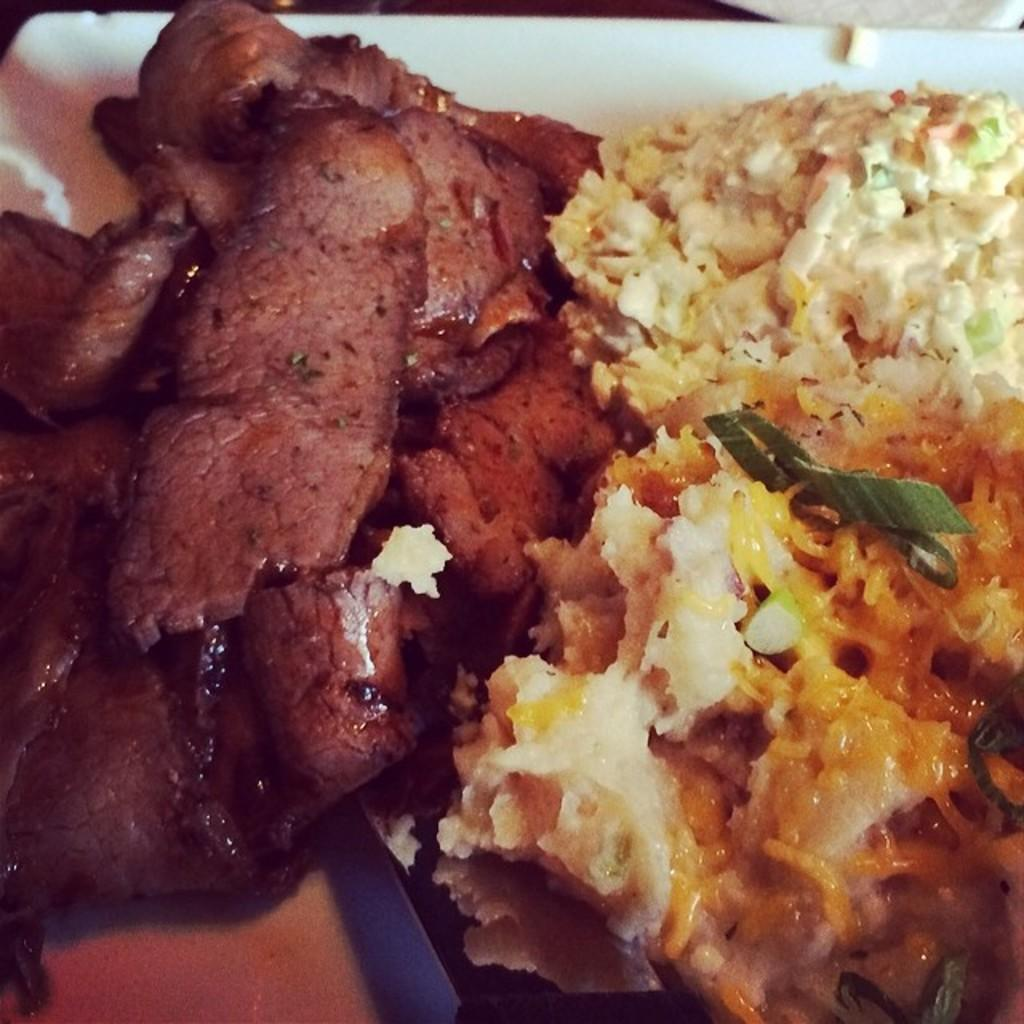What object is present on the table in the image? There is a plate in the image. What is the color of the plate? The plate is white in color. What is on top of the plate? There is a food item on the plate. What utensil is visible in the image? There is a spoon in the image. What type of sign can be seen in the image? There is no sign present in the image. Is there a drum visible in the image? There is no drum present in the image. 